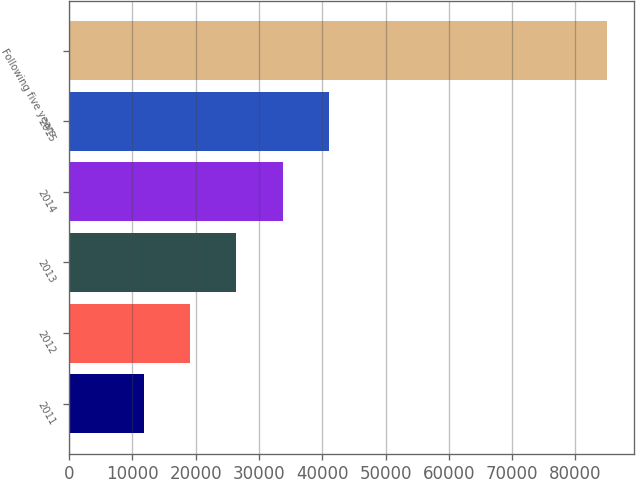Convert chart. <chart><loc_0><loc_0><loc_500><loc_500><bar_chart><fcel>2011<fcel>2012<fcel>2013<fcel>2014<fcel>2015<fcel>Following five years<nl><fcel>11805<fcel>19120.9<fcel>26436.8<fcel>33752.7<fcel>41068.6<fcel>84964<nl></chart> 